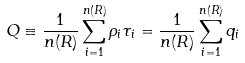Convert formula to latex. <formula><loc_0><loc_0><loc_500><loc_500>Q \equiv \frac { 1 } { n ( R ) } \sum _ { i = 1 } ^ { n ( R ) } \rho _ { i } \tau _ { i } = \frac { 1 } { n ( R ) } \sum _ { i = 1 } ^ { n ( R ) } q _ { i }</formula> 